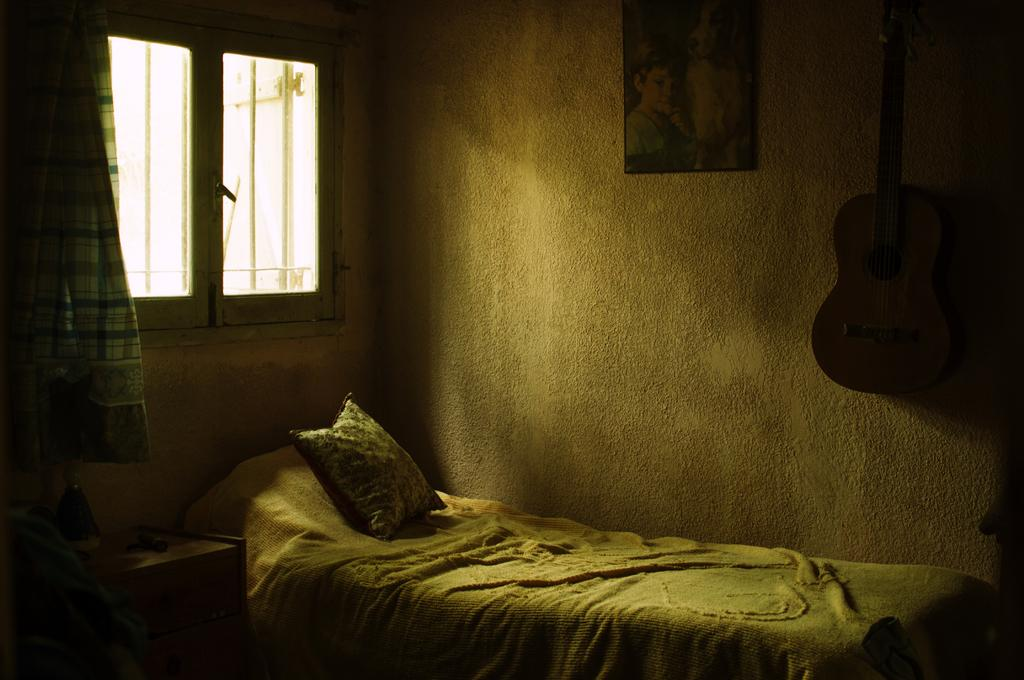What object can be seen on the bed in the image? There is a bed pillow in the image. What is hanging on the wall in the image? There is a photo frame and a guitar hanging on the wall in the image. What is the profit margin of the guitar in the image? There is no information about the profit margin of the guitar in the image, as it is not relevant to the objects or setting depicted. 